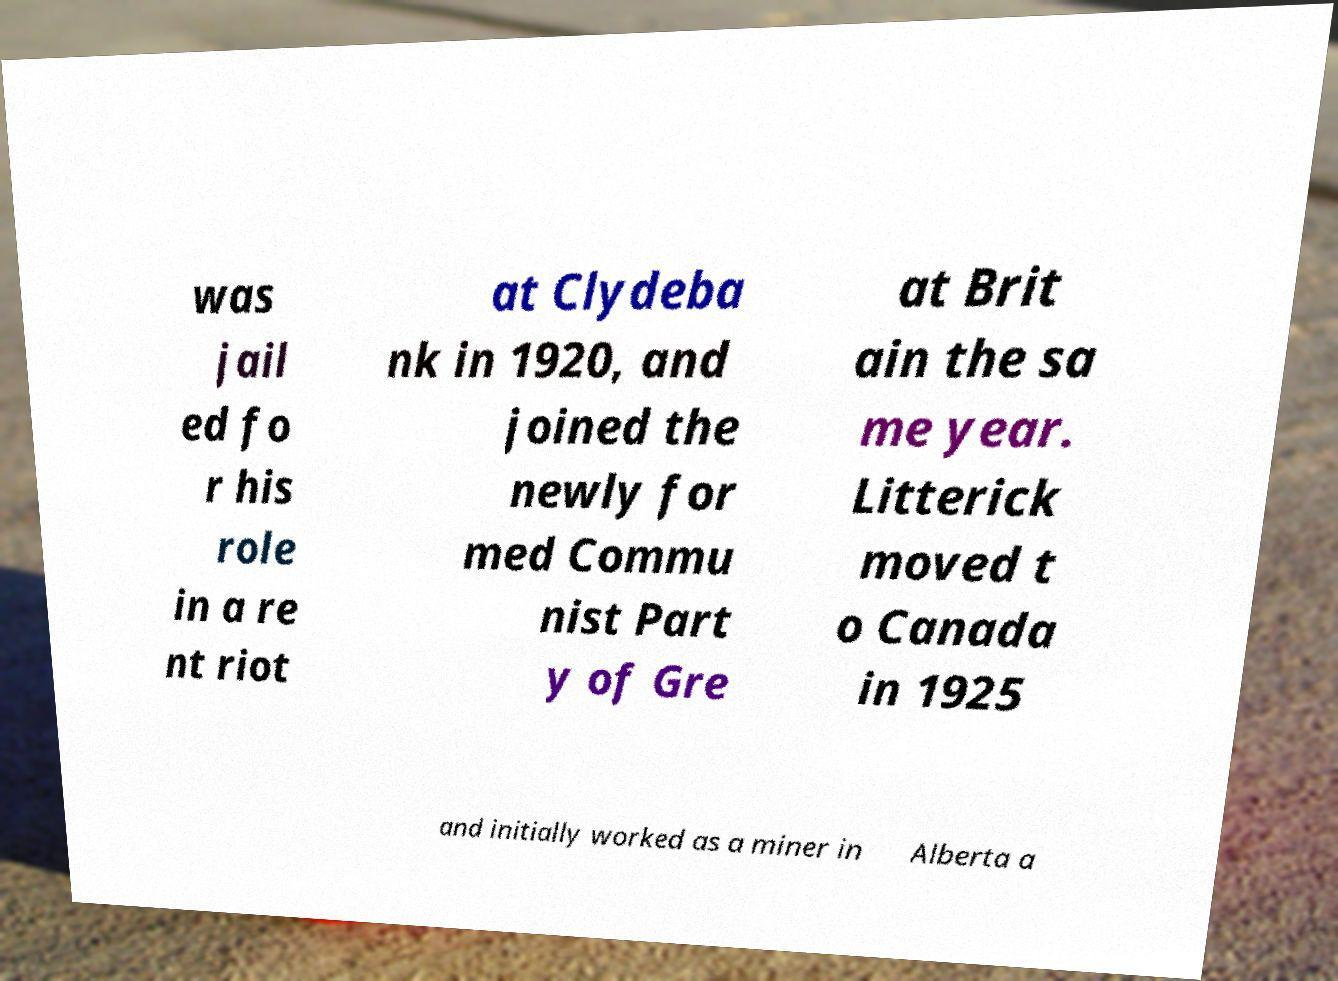What messages or text are displayed in this image? I need them in a readable, typed format. was jail ed fo r his role in a re nt riot at Clydeba nk in 1920, and joined the newly for med Commu nist Part y of Gre at Brit ain the sa me year. Litterick moved t o Canada in 1925 and initially worked as a miner in Alberta a 